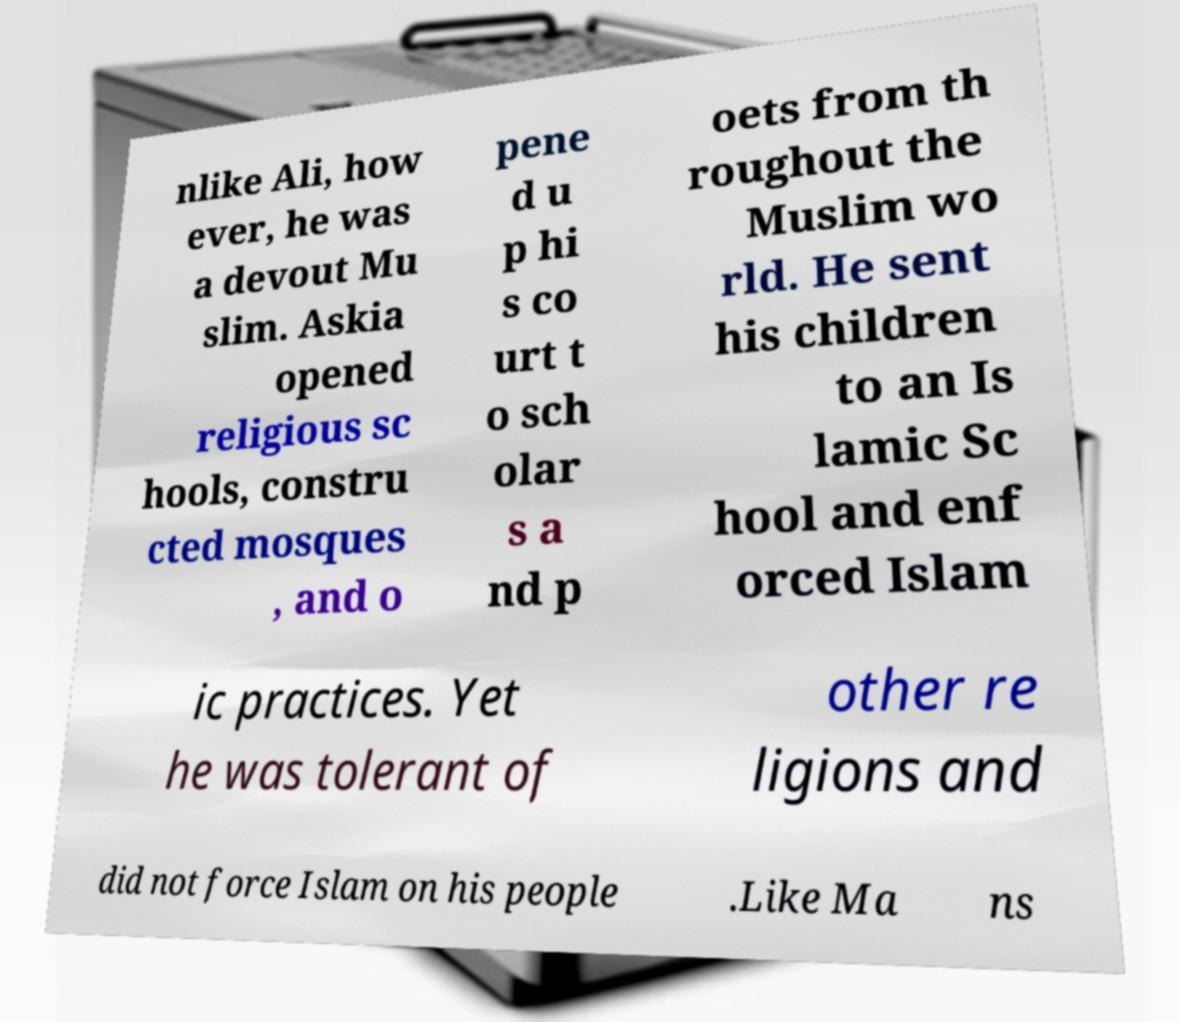For documentation purposes, I need the text within this image transcribed. Could you provide that? nlike Ali, how ever, he was a devout Mu slim. Askia opened religious sc hools, constru cted mosques , and o pene d u p hi s co urt t o sch olar s a nd p oets from th roughout the Muslim wo rld. He sent his children to an Is lamic Sc hool and enf orced Islam ic practices. Yet he was tolerant of other re ligions and did not force Islam on his people .Like Ma ns 